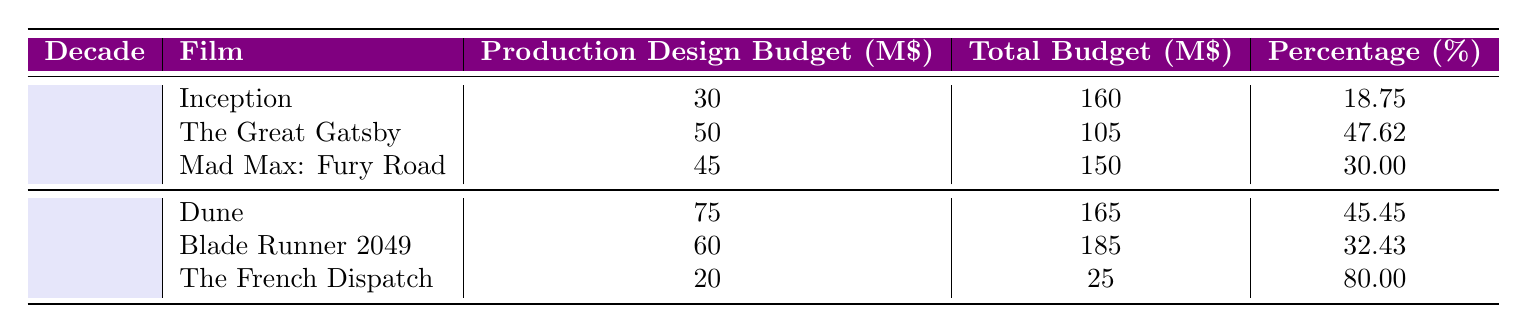What is the highest production design budget in the 2010s? The highest production design budget in the 2010s can be found by comparing the production design budgets listed for each film in that decade. The budgets are 30, 50, and 45 for "Inception," "The Great Gatsby," and "Mad Max: Fury Road" respectively. The highest value among these is 50, which corresponds to "The Great Gatsby."
Answer: 50 Which film in the 2020s has the lowest production design budget? Looking at the production design budgets listed for the films in the 2020s, we have budgets of 75 for "Dune," 60 for "Blade Runner 2049," and 20 for "The French Dispatch." Comparing these, "The French Dispatch" has the lowest budget of 20.
Answer: 20 What is the average production design budget for films in the 2010s? To find the average production design budget for the 2010s, we sum the budgets (30 + 50 + 45 = 125) and then divide by the number of films (3). The average budget is 125 / 3 = 41.67.
Answer: 41.67 Is the production design budget for "Blade Runner 2049" more than 50 million dollars? The production design budget for "Blade Runner 2049" is listed as 60 million dollars. Since 60 is greater than 50, the statement is true.
Answer: Yes What is the percentage of the production design budget to the total budget for "Dune"? The percentage is calculated by dividing the production design budget (75) by the total budget (165) and then multiplying by 100. Therefore, (75 / 165) * 100 = 45.45%.
Answer: 45.45 Which decade had a film with the highest percentage of production design budget relative to its total budget? In the 2010s, "The Great Gatsby" has a production design budget percentage of 47.62%. In the 2020s, "The French Dispatch" has 80.00%. Comparing both, the highest percentage is 80.00%, which is from "The French Dispatch" in the 2020s.
Answer: 2020s How much more was spent on production design for "The Great Gatsby" compared to "Inception"? The production design budgets are 50 for "The Great Gatsby" and 30 for "Inception." The difference is calculated by subtracting the lower budget from the higher: 50 - 30 = 20.
Answer: 20 What is the total production design budget for all films listed in the 2020s? To find the total production design budget, we sum the budgets of all three films in the 2020s: 75 for "Dune," 60 for "Blade Runner 2049," and 20 for "The French Dispatch." The total is 75 + 60 + 20 = 155 million dollars.
Answer: 155 